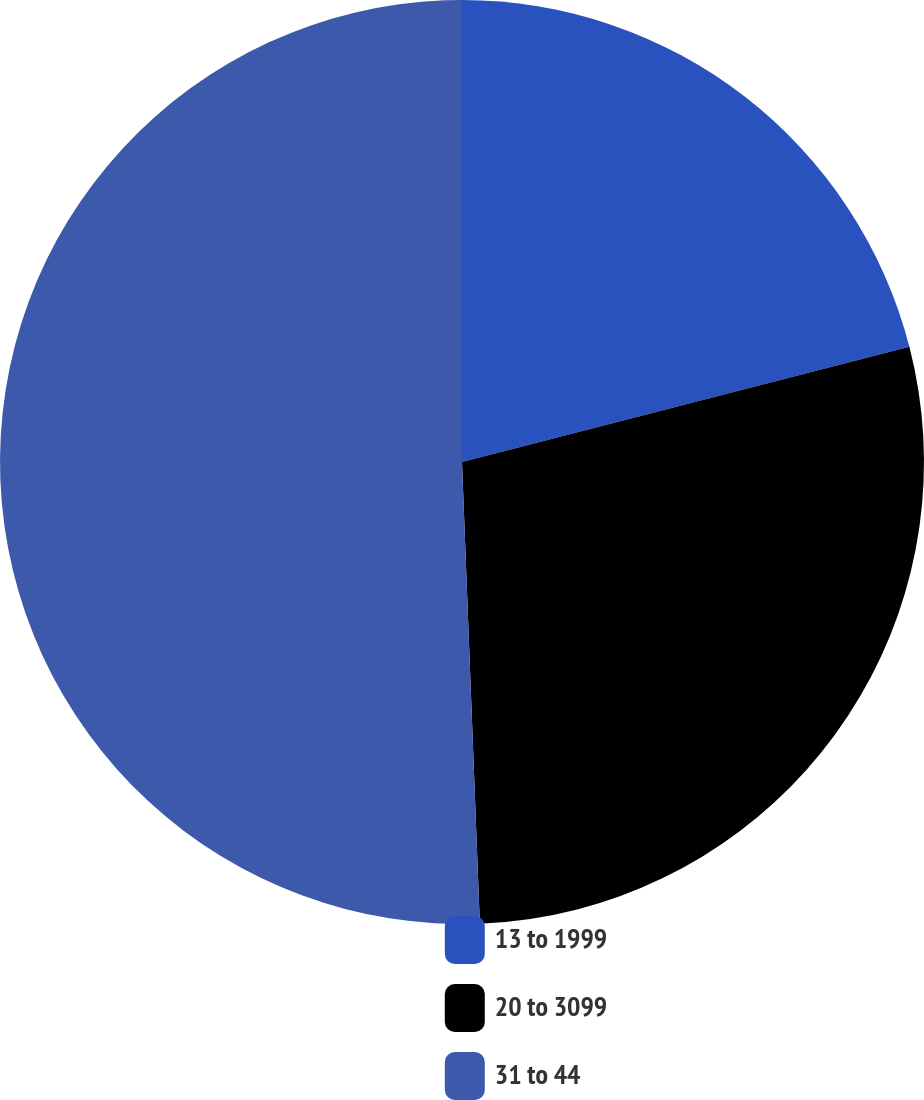Convert chart. <chart><loc_0><loc_0><loc_500><loc_500><pie_chart><fcel>13 to 1999<fcel>20 to 3099<fcel>31 to 44<nl><fcel>20.99%<fcel>28.4%<fcel>50.62%<nl></chart> 